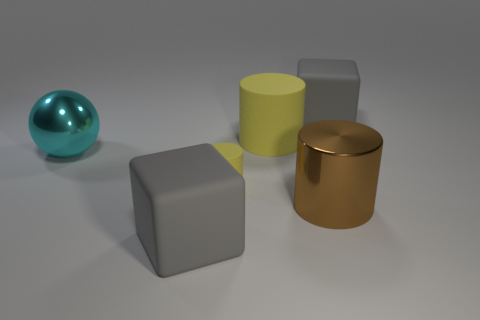How many gray blocks must be subtracted to get 1 gray blocks? 1 Subtract all matte cylinders. How many cylinders are left? 1 Subtract all brown cylinders. How many cylinders are left? 2 Add 1 large shiny cylinders. How many objects exist? 7 Subtract all spheres. How many objects are left? 5 Subtract all yellow blocks. Subtract all cyan cylinders. How many blocks are left? 2 Subtract all red balls. How many brown cylinders are left? 1 Subtract all big yellow rubber things. Subtract all big rubber cylinders. How many objects are left? 4 Add 3 big yellow matte cylinders. How many big yellow matte cylinders are left? 4 Add 3 large cyan balls. How many large cyan balls exist? 4 